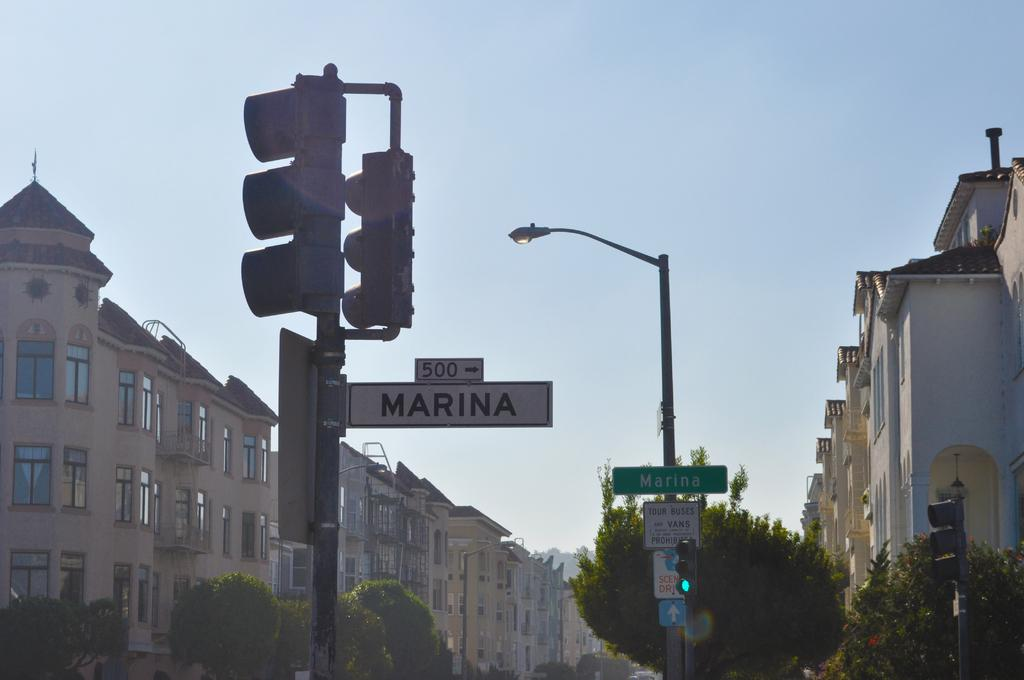What type of structures can be seen in the image? There are buildings in the image. What other natural elements are present in the image? There are trees in the image. What can be found on the poles in the image? There is a pole with traffic signal lights and a pole light in the image. What are the boards used for in the image? The purpose of the boards in the image is not specified, but they could be used for signage or advertisements. How would you describe the weather in the image? The sky is cloudy in the image, suggesting a potentially overcast or cloudy day. Can you see any rocks in the image? There are no rocks visible in the image. How many knots are tied on the traffic signal pole in the image? There are no knots present on the traffic signal pole in the image. 